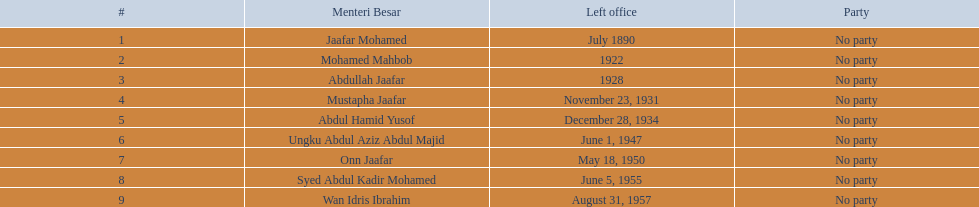Which menteri besars took office in the 1920's? Mohamed Mahbob, Abdullah Jaafar, Mustapha Jaafar. Parse the table in full. {'header': ['#', 'Menteri Besar', 'Left office', 'Party'], 'rows': [['1', 'Jaafar Mohamed', 'July 1890', 'No party'], ['2', 'Mohamed Mahbob', '1922', 'No party'], ['3', 'Abdullah Jaafar', '1928', 'No party'], ['4', 'Mustapha Jaafar', 'November 23, 1931', 'No party'], ['5', 'Abdul Hamid Yusof', 'December 28, 1934', 'No party'], ['6', 'Ungku Abdul Aziz Abdul Majid', 'June 1, 1947', 'No party'], ['7', 'Onn Jaafar', 'May 18, 1950', 'No party'], ['8', 'Syed Abdul Kadir Mohamed', 'June 5, 1955', 'No party'], ['9', 'Wan Idris Ibrahim', 'August 31, 1957', 'No party']]} Of those men, who was only in office for 2 years? Mohamed Mahbob. 